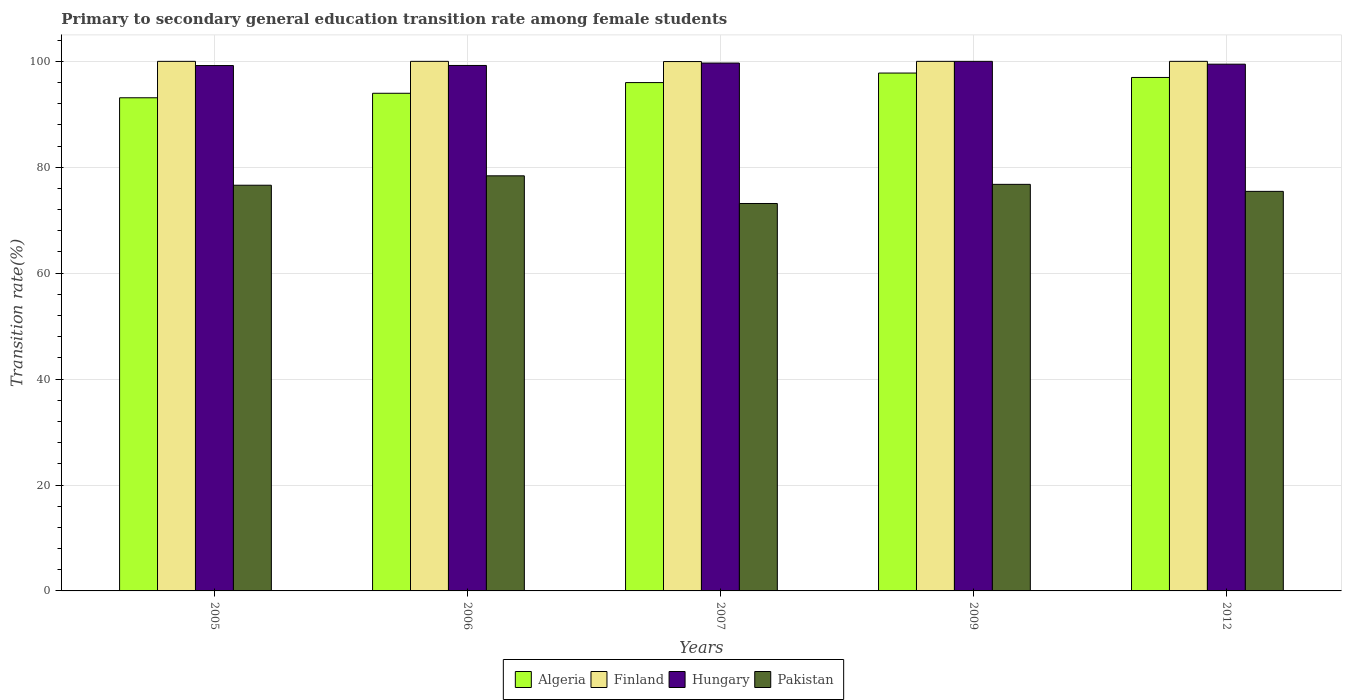How many different coloured bars are there?
Offer a terse response. 4. Are the number of bars per tick equal to the number of legend labels?
Keep it short and to the point. Yes. Are the number of bars on each tick of the X-axis equal?
Keep it short and to the point. Yes. How many bars are there on the 5th tick from the left?
Your answer should be very brief. 4. How many bars are there on the 2nd tick from the right?
Offer a terse response. 4. In how many cases, is the number of bars for a given year not equal to the number of legend labels?
Make the answer very short. 0. What is the transition rate in Pakistan in 2012?
Keep it short and to the point. 75.45. Across all years, what is the minimum transition rate in Algeria?
Your answer should be very brief. 93.12. What is the total transition rate in Hungary in the graph?
Offer a terse response. 497.57. What is the difference between the transition rate in Hungary in 2005 and that in 2012?
Your answer should be compact. -0.26. What is the difference between the transition rate in Hungary in 2009 and the transition rate in Finland in 2012?
Offer a very short reply. 0. What is the average transition rate in Pakistan per year?
Offer a terse response. 76.07. In the year 2012, what is the difference between the transition rate in Finland and transition rate in Pakistan?
Give a very brief answer. 24.55. In how many years, is the transition rate in Pakistan greater than 84 %?
Your answer should be very brief. 0. What is the ratio of the transition rate in Algeria in 2006 to that in 2009?
Your answer should be very brief. 0.96. Is the transition rate in Algeria in 2005 less than that in 2006?
Your answer should be compact. Yes. Is the difference between the transition rate in Finland in 2005 and 2007 greater than the difference between the transition rate in Pakistan in 2005 and 2007?
Your response must be concise. No. What is the difference between the highest and the lowest transition rate in Finland?
Ensure brevity in your answer.  0.04. In how many years, is the transition rate in Finland greater than the average transition rate in Finland taken over all years?
Ensure brevity in your answer.  4. Is it the case that in every year, the sum of the transition rate in Hungary and transition rate in Finland is greater than the sum of transition rate in Algeria and transition rate in Pakistan?
Keep it short and to the point. Yes. What does the 1st bar from the left in 2012 represents?
Provide a succinct answer. Algeria. What does the 3rd bar from the right in 2006 represents?
Your answer should be very brief. Finland. Is it the case that in every year, the sum of the transition rate in Finland and transition rate in Pakistan is greater than the transition rate in Algeria?
Provide a short and direct response. Yes. How many bars are there?
Provide a succinct answer. 20. How many years are there in the graph?
Offer a terse response. 5. Are the values on the major ticks of Y-axis written in scientific E-notation?
Offer a very short reply. No. Does the graph contain grids?
Provide a succinct answer. Yes. How are the legend labels stacked?
Your answer should be compact. Horizontal. What is the title of the graph?
Your answer should be very brief. Primary to secondary general education transition rate among female students. Does "Latin America(developing only)" appear as one of the legend labels in the graph?
Your answer should be very brief. No. What is the label or title of the Y-axis?
Offer a terse response. Transition rate(%). What is the Transition rate(%) in Algeria in 2005?
Offer a terse response. 93.12. What is the Transition rate(%) in Finland in 2005?
Your answer should be compact. 100. What is the Transition rate(%) of Hungary in 2005?
Offer a very short reply. 99.21. What is the Transition rate(%) in Pakistan in 2005?
Your answer should be very brief. 76.61. What is the Transition rate(%) of Algeria in 2006?
Offer a terse response. 93.97. What is the Transition rate(%) in Finland in 2006?
Offer a very short reply. 100. What is the Transition rate(%) of Hungary in 2006?
Provide a succinct answer. 99.22. What is the Transition rate(%) of Pakistan in 2006?
Ensure brevity in your answer.  78.38. What is the Transition rate(%) in Algeria in 2007?
Your response must be concise. 95.99. What is the Transition rate(%) in Finland in 2007?
Keep it short and to the point. 99.96. What is the Transition rate(%) in Hungary in 2007?
Your response must be concise. 99.68. What is the Transition rate(%) of Pakistan in 2007?
Your answer should be compact. 73.16. What is the Transition rate(%) of Algeria in 2009?
Provide a short and direct response. 97.79. What is the Transition rate(%) in Pakistan in 2009?
Provide a short and direct response. 76.77. What is the Transition rate(%) of Algeria in 2012?
Provide a succinct answer. 96.96. What is the Transition rate(%) of Hungary in 2012?
Offer a very short reply. 99.47. What is the Transition rate(%) of Pakistan in 2012?
Provide a short and direct response. 75.45. Across all years, what is the maximum Transition rate(%) of Algeria?
Give a very brief answer. 97.79. Across all years, what is the maximum Transition rate(%) of Pakistan?
Ensure brevity in your answer.  78.38. Across all years, what is the minimum Transition rate(%) in Algeria?
Your response must be concise. 93.12. Across all years, what is the minimum Transition rate(%) of Finland?
Give a very brief answer. 99.96. Across all years, what is the minimum Transition rate(%) of Hungary?
Make the answer very short. 99.21. Across all years, what is the minimum Transition rate(%) of Pakistan?
Ensure brevity in your answer.  73.16. What is the total Transition rate(%) of Algeria in the graph?
Give a very brief answer. 477.84. What is the total Transition rate(%) of Finland in the graph?
Your answer should be compact. 499.96. What is the total Transition rate(%) in Hungary in the graph?
Keep it short and to the point. 497.57. What is the total Transition rate(%) in Pakistan in the graph?
Provide a short and direct response. 380.37. What is the difference between the Transition rate(%) in Algeria in 2005 and that in 2006?
Ensure brevity in your answer.  -0.85. What is the difference between the Transition rate(%) of Hungary in 2005 and that in 2006?
Your response must be concise. -0.02. What is the difference between the Transition rate(%) in Pakistan in 2005 and that in 2006?
Your answer should be very brief. -1.78. What is the difference between the Transition rate(%) of Algeria in 2005 and that in 2007?
Keep it short and to the point. -2.87. What is the difference between the Transition rate(%) in Finland in 2005 and that in 2007?
Your response must be concise. 0.04. What is the difference between the Transition rate(%) in Hungary in 2005 and that in 2007?
Your answer should be very brief. -0.47. What is the difference between the Transition rate(%) of Pakistan in 2005 and that in 2007?
Keep it short and to the point. 3.45. What is the difference between the Transition rate(%) of Algeria in 2005 and that in 2009?
Your answer should be very brief. -4.67. What is the difference between the Transition rate(%) in Hungary in 2005 and that in 2009?
Your answer should be very brief. -0.79. What is the difference between the Transition rate(%) of Pakistan in 2005 and that in 2009?
Ensure brevity in your answer.  -0.17. What is the difference between the Transition rate(%) in Algeria in 2005 and that in 2012?
Offer a very short reply. -3.84. What is the difference between the Transition rate(%) of Finland in 2005 and that in 2012?
Give a very brief answer. 0. What is the difference between the Transition rate(%) of Hungary in 2005 and that in 2012?
Keep it short and to the point. -0.26. What is the difference between the Transition rate(%) in Pakistan in 2005 and that in 2012?
Your answer should be very brief. 1.16. What is the difference between the Transition rate(%) of Algeria in 2006 and that in 2007?
Your answer should be compact. -2.02. What is the difference between the Transition rate(%) of Finland in 2006 and that in 2007?
Your response must be concise. 0.04. What is the difference between the Transition rate(%) of Hungary in 2006 and that in 2007?
Provide a succinct answer. -0.46. What is the difference between the Transition rate(%) in Pakistan in 2006 and that in 2007?
Provide a short and direct response. 5.23. What is the difference between the Transition rate(%) in Algeria in 2006 and that in 2009?
Give a very brief answer. -3.82. What is the difference between the Transition rate(%) in Hungary in 2006 and that in 2009?
Provide a short and direct response. -0.78. What is the difference between the Transition rate(%) in Pakistan in 2006 and that in 2009?
Give a very brief answer. 1.61. What is the difference between the Transition rate(%) in Algeria in 2006 and that in 2012?
Provide a succinct answer. -2.99. What is the difference between the Transition rate(%) of Hungary in 2006 and that in 2012?
Make the answer very short. -0.24. What is the difference between the Transition rate(%) in Pakistan in 2006 and that in 2012?
Give a very brief answer. 2.93. What is the difference between the Transition rate(%) of Algeria in 2007 and that in 2009?
Ensure brevity in your answer.  -1.8. What is the difference between the Transition rate(%) of Finland in 2007 and that in 2009?
Offer a terse response. -0.04. What is the difference between the Transition rate(%) of Hungary in 2007 and that in 2009?
Your answer should be very brief. -0.32. What is the difference between the Transition rate(%) of Pakistan in 2007 and that in 2009?
Your answer should be compact. -3.62. What is the difference between the Transition rate(%) in Algeria in 2007 and that in 2012?
Provide a short and direct response. -0.97. What is the difference between the Transition rate(%) of Finland in 2007 and that in 2012?
Offer a terse response. -0.04. What is the difference between the Transition rate(%) of Hungary in 2007 and that in 2012?
Make the answer very short. 0.21. What is the difference between the Transition rate(%) in Pakistan in 2007 and that in 2012?
Offer a very short reply. -2.29. What is the difference between the Transition rate(%) in Algeria in 2009 and that in 2012?
Offer a terse response. 0.83. What is the difference between the Transition rate(%) in Hungary in 2009 and that in 2012?
Offer a very short reply. 0.53. What is the difference between the Transition rate(%) in Pakistan in 2009 and that in 2012?
Make the answer very short. 1.32. What is the difference between the Transition rate(%) of Algeria in 2005 and the Transition rate(%) of Finland in 2006?
Offer a very short reply. -6.88. What is the difference between the Transition rate(%) in Algeria in 2005 and the Transition rate(%) in Hungary in 2006?
Give a very brief answer. -6.1. What is the difference between the Transition rate(%) in Algeria in 2005 and the Transition rate(%) in Pakistan in 2006?
Make the answer very short. 14.74. What is the difference between the Transition rate(%) of Finland in 2005 and the Transition rate(%) of Hungary in 2006?
Provide a succinct answer. 0.78. What is the difference between the Transition rate(%) in Finland in 2005 and the Transition rate(%) in Pakistan in 2006?
Offer a terse response. 21.62. What is the difference between the Transition rate(%) in Hungary in 2005 and the Transition rate(%) in Pakistan in 2006?
Ensure brevity in your answer.  20.82. What is the difference between the Transition rate(%) in Algeria in 2005 and the Transition rate(%) in Finland in 2007?
Your answer should be compact. -6.84. What is the difference between the Transition rate(%) in Algeria in 2005 and the Transition rate(%) in Hungary in 2007?
Provide a succinct answer. -6.56. What is the difference between the Transition rate(%) in Algeria in 2005 and the Transition rate(%) in Pakistan in 2007?
Provide a succinct answer. 19.96. What is the difference between the Transition rate(%) of Finland in 2005 and the Transition rate(%) of Hungary in 2007?
Make the answer very short. 0.32. What is the difference between the Transition rate(%) of Finland in 2005 and the Transition rate(%) of Pakistan in 2007?
Offer a very short reply. 26.84. What is the difference between the Transition rate(%) of Hungary in 2005 and the Transition rate(%) of Pakistan in 2007?
Your answer should be compact. 26.05. What is the difference between the Transition rate(%) in Algeria in 2005 and the Transition rate(%) in Finland in 2009?
Your answer should be compact. -6.88. What is the difference between the Transition rate(%) in Algeria in 2005 and the Transition rate(%) in Hungary in 2009?
Your answer should be compact. -6.88. What is the difference between the Transition rate(%) in Algeria in 2005 and the Transition rate(%) in Pakistan in 2009?
Provide a short and direct response. 16.35. What is the difference between the Transition rate(%) in Finland in 2005 and the Transition rate(%) in Pakistan in 2009?
Your answer should be very brief. 23.23. What is the difference between the Transition rate(%) of Hungary in 2005 and the Transition rate(%) of Pakistan in 2009?
Your response must be concise. 22.43. What is the difference between the Transition rate(%) in Algeria in 2005 and the Transition rate(%) in Finland in 2012?
Ensure brevity in your answer.  -6.88. What is the difference between the Transition rate(%) of Algeria in 2005 and the Transition rate(%) of Hungary in 2012?
Keep it short and to the point. -6.34. What is the difference between the Transition rate(%) in Algeria in 2005 and the Transition rate(%) in Pakistan in 2012?
Offer a very short reply. 17.67. What is the difference between the Transition rate(%) in Finland in 2005 and the Transition rate(%) in Hungary in 2012?
Your response must be concise. 0.53. What is the difference between the Transition rate(%) in Finland in 2005 and the Transition rate(%) in Pakistan in 2012?
Give a very brief answer. 24.55. What is the difference between the Transition rate(%) of Hungary in 2005 and the Transition rate(%) of Pakistan in 2012?
Offer a very short reply. 23.76. What is the difference between the Transition rate(%) in Algeria in 2006 and the Transition rate(%) in Finland in 2007?
Give a very brief answer. -5.99. What is the difference between the Transition rate(%) of Algeria in 2006 and the Transition rate(%) of Hungary in 2007?
Ensure brevity in your answer.  -5.71. What is the difference between the Transition rate(%) of Algeria in 2006 and the Transition rate(%) of Pakistan in 2007?
Your answer should be very brief. 20.81. What is the difference between the Transition rate(%) of Finland in 2006 and the Transition rate(%) of Hungary in 2007?
Make the answer very short. 0.32. What is the difference between the Transition rate(%) in Finland in 2006 and the Transition rate(%) in Pakistan in 2007?
Give a very brief answer. 26.84. What is the difference between the Transition rate(%) of Hungary in 2006 and the Transition rate(%) of Pakistan in 2007?
Ensure brevity in your answer.  26.07. What is the difference between the Transition rate(%) of Algeria in 2006 and the Transition rate(%) of Finland in 2009?
Your answer should be very brief. -6.03. What is the difference between the Transition rate(%) of Algeria in 2006 and the Transition rate(%) of Hungary in 2009?
Provide a succinct answer. -6.03. What is the difference between the Transition rate(%) in Algeria in 2006 and the Transition rate(%) in Pakistan in 2009?
Offer a terse response. 17.2. What is the difference between the Transition rate(%) in Finland in 2006 and the Transition rate(%) in Pakistan in 2009?
Make the answer very short. 23.23. What is the difference between the Transition rate(%) of Hungary in 2006 and the Transition rate(%) of Pakistan in 2009?
Your answer should be compact. 22.45. What is the difference between the Transition rate(%) of Algeria in 2006 and the Transition rate(%) of Finland in 2012?
Offer a very short reply. -6.03. What is the difference between the Transition rate(%) in Algeria in 2006 and the Transition rate(%) in Hungary in 2012?
Keep it short and to the point. -5.49. What is the difference between the Transition rate(%) of Algeria in 2006 and the Transition rate(%) of Pakistan in 2012?
Your answer should be very brief. 18.52. What is the difference between the Transition rate(%) in Finland in 2006 and the Transition rate(%) in Hungary in 2012?
Your answer should be very brief. 0.53. What is the difference between the Transition rate(%) in Finland in 2006 and the Transition rate(%) in Pakistan in 2012?
Your response must be concise. 24.55. What is the difference between the Transition rate(%) in Hungary in 2006 and the Transition rate(%) in Pakistan in 2012?
Make the answer very short. 23.77. What is the difference between the Transition rate(%) of Algeria in 2007 and the Transition rate(%) of Finland in 2009?
Offer a very short reply. -4.01. What is the difference between the Transition rate(%) of Algeria in 2007 and the Transition rate(%) of Hungary in 2009?
Your answer should be very brief. -4.01. What is the difference between the Transition rate(%) of Algeria in 2007 and the Transition rate(%) of Pakistan in 2009?
Offer a terse response. 19.22. What is the difference between the Transition rate(%) in Finland in 2007 and the Transition rate(%) in Hungary in 2009?
Make the answer very short. -0.04. What is the difference between the Transition rate(%) in Finland in 2007 and the Transition rate(%) in Pakistan in 2009?
Your response must be concise. 23.19. What is the difference between the Transition rate(%) in Hungary in 2007 and the Transition rate(%) in Pakistan in 2009?
Provide a short and direct response. 22.9. What is the difference between the Transition rate(%) in Algeria in 2007 and the Transition rate(%) in Finland in 2012?
Provide a succinct answer. -4.01. What is the difference between the Transition rate(%) in Algeria in 2007 and the Transition rate(%) in Hungary in 2012?
Offer a terse response. -3.48. What is the difference between the Transition rate(%) in Algeria in 2007 and the Transition rate(%) in Pakistan in 2012?
Your answer should be compact. 20.54. What is the difference between the Transition rate(%) in Finland in 2007 and the Transition rate(%) in Hungary in 2012?
Offer a very short reply. 0.5. What is the difference between the Transition rate(%) of Finland in 2007 and the Transition rate(%) of Pakistan in 2012?
Provide a short and direct response. 24.51. What is the difference between the Transition rate(%) of Hungary in 2007 and the Transition rate(%) of Pakistan in 2012?
Provide a succinct answer. 24.23. What is the difference between the Transition rate(%) of Algeria in 2009 and the Transition rate(%) of Finland in 2012?
Your answer should be very brief. -2.21. What is the difference between the Transition rate(%) in Algeria in 2009 and the Transition rate(%) in Hungary in 2012?
Your answer should be very brief. -1.67. What is the difference between the Transition rate(%) in Algeria in 2009 and the Transition rate(%) in Pakistan in 2012?
Ensure brevity in your answer.  22.34. What is the difference between the Transition rate(%) of Finland in 2009 and the Transition rate(%) of Hungary in 2012?
Offer a terse response. 0.53. What is the difference between the Transition rate(%) in Finland in 2009 and the Transition rate(%) in Pakistan in 2012?
Provide a short and direct response. 24.55. What is the difference between the Transition rate(%) of Hungary in 2009 and the Transition rate(%) of Pakistan in 2012?
Your answer should be very brief. 24.55. What is the average Transition rate(%) in Algeria per year?
Ensure brevity in your answer.  95.57. What is the average Transition rate(%) of Finland per year?
Keep it short and to the point. 99.99. What is the average Transition rate(%) in Hungary per year?
Offer a very short reply. 99.52. What is the average Transition rate(%) in Pakistan per year?
Make the answer very short. 76.07. In the year 2005, what is the difference between the Transition rate(%) of Algeria and Transition rate(%) of Finland?
Offer a very short reply. -6.88. In the year 2005, what is the difference between the Transition rate(%) of Algeria and Transition rate(%) of Hungary?
Offer a very short reply. -6.08. In the year 2005, what is the difference between the Transition rate(%) in Algeria and Transition rate(%) in Pakistan?
Ensure brevity in your answer.  16.52. In the year 2005, what is the difference between the Transition rate(%) in Finland and Transition rate(%) in Hungary?
Your response must be concise. 0.79. In the year 2005, what is the difference between the Transition rate(%) in Finland and Transition rate(%) in Pakistan?
Provide a short and direct response. 23.39. In the year 2005, what is the difference between the Transition rate(%) in Hungary and Transition rate(%) in Pakistan?
Your response must be concise. 22.6. In the year 2006, what is the difference between the Transition rate(%) of Algeria and Transition rate(%) of Finland?
Give a very brief answer. -6.03. In the year 2006, what is the difference between the Transition rate(%) in Algeria and Transition rate(%) in Hungary?
Your answer should be compact. -5.25. In the year 2006, what is the difference between the Transition rate(%) of Algeria and Transition rate(%) of Pakistan?
Make the answer very short. 15.59. In the year 2006, what is the difference between the Transition rate(%) of Finland and Transition rate(%) of Hungary?
Provide a succinct answer. 0.78. In the year 2006, what is the difference between the Transition rate(%) in Finland and Transition rate(%) in Pakistan?
Offer a terse response. 21.62. In the year 2006, what is the difference between the Transition rate(%) in Hungary and Transition rate(%) in Pakistan?
Your answer should be very brief. 20.84. In the year 2007, what is the difference between the Transition rate(%) in Algeria and Transition rate(%) in Finland?
Keep it short and to the point. -3.97. In the year 2007, what is the difference between the Transition rate(%) in Algeria and Transition rate(%) in Hungary?
Make the answer very short. -3.69. In the year 2007, what is the difference between the Transition rate(%) of Algeria and Transition rate(%) of Pakistan?
Offer a terse response. 22.83. In the year 2007, what is the difference between the Transition rate(%) of Finland and Transition rate(%) of Hungary?
Offer a terse response. 0.28. In the year 2007, what is the difference between the Transition rate(%) of Finland and Transition rate(%) of Pakistan?
Offer a terse response. 26.8. In the year 2007, what is the difference between the Transition rate(%) in Hungary and Transition rate(%) in Pakistan?
Ensure brevity in your answer.  26.52. In the year 2009, what is the difference between the Transition rate(%) in Algeria and Transition rate(%) in Finland?
Offer a very short reply. -2.21. In the year 2009, what is the difference between the Transition rate(%) in Algeria and Transition rate(%) in Hungary?
Your answer should be compact. -2.21. In the year 2009, what is the difference between the Transition rate(%) in Algeria and Transition rate(%) in Pakistan?
Provide a succinct answer. 21.02. In the year 2009, what is the difference between the Transition rate(%) of Finland and Transition rate(%) of Pakistan?
Provide a succinct answer. 23.23. In the year 2009, what is the difference between the Transition rate(%) of Hungary and Transition rate(%) of Pakistan?
Offer a terse response. 23.23. In the year 2012, what is the difference between the Transition rate(%) in Algeria and Transition rate(%) in Finland?
Provide a short and direct response. -3.04. In the year 2012, what is the difference between the Transition rate(%) of Algeria and Transition rate(%) of Hungary?
Provide a succinct answer. -2.51. In the year 2012, what is the difference between the Transition rate(%) of Algeria and Transition rate(%) of Pakistan?
Offer a very short reply. 21.51. In the year 2012, what is the difference between the Transition rate(%) of Finland and Transition rate(%) of Hungary?
Offer a very short reply. 0.53. In the year 2012, what is the difference between the Transition rate(%) in Finland and Transition rate(%) in Pakistan?
Keep it short and to the point. 24.55. In the year 2012, what is the difference between the Transition rate(%) in Hungary and Transition rate(%) in Pakistan?
Your answer should be compact. 24.02. What is the ratio of the Transition rate(%) of Algeria in 2005 to that in 2006?
Provide a short and direct response. 0.99. What is the ratio of the Transition rate(%) of Finland in 2005 to that in 2006?
Offer a very short reply. 1. What is the ratio of the Transition rate(%) of Hungary in 2005 to that in 2006?
Offer a terse response. 1. What is the ratio of the Transition rate(%) in Pakistan in 2005 to that in 2006?
Your answer should be compact. 0.98. What is the ratio of the Transition rate(%) of Algeria in 2005 to that in 2007?
Give a very brief answer. 0.97. What is the ratio of the Transition rate(%) of Finland in 2005 to that in 2007?
Offer a very short reply. 1. What is the ratio of the Transition rate(%) in Pakistan in 2005 to that in 2007?
Your answer should be very brief. 1.05. What is the ratio of the Transition rate(%) of Algeria in 2005 to that in 2009?
Offer a terse response. 0.95. What is the ratio of the Transition rate(%) in Pakistan in 2005 to that in 2009?
Provide a short and direct response. 1. What is the ratio of the Transition rate(%) of Algeria in 2005 to that in 2012?
Keep it short and to the point. 0.96. What is the ratio of the Transition rate(%) in Finland in 2005 to that in 2012?
Your response must be concise. 1. What is the ratio of the Transition rate(%) of Hungary in 2005 to that in 2012?
Provide a succinct answer. 1. What is the ratio of the Transition rate(%) in Pakistan in 2005 to that in 2012?
Keep it short and to the point. 1.02. What is the ratio of the Transition rate(%) in Algeria in 2006 to that in 2007?
Your answer should be very brief. 0.98. What is the ratio of the Transition rate(%) in Hungary in 2006 to that in 2007?
Keep it short and to the point. 1. What is the ratio of the Transition rate(%) of Pakistan in 2006 to that in 2007?
Your answer should be compact. 1.07. What is the ratio of the Transition rate(%) of Algeria in 2006 to that in 2009?
Ensure brevity in your answer.  0.96. What is the ratio of the Transition rate(%) in Hungary in 2006 to that in 2009?
Ensure brevity in your answer.  0.99. What is the ratio of the Transition rate(%) in Algeria in 2006 to that in 2012?
Your response must be concise. 0.97. What is the ratio of the Transition rate(%) in Finland in 2006 to that in 2012?
Offer a very short reply. 1. What is the ratio of the Transition rate(%) of Hungary in 2006 to that in 2012?
Give a very brief answer. 1. What is the ratio of the Transition rate(%) of Pakistan in 2006 to that in 2012?
Your answer should be compact. 1.04. What is the ratio of the Transition rate(%) of Algeria in 2007 to that in 2009?
Keep it short and to the point. 0.98. What is the ratio of the Transition rate(%) in Hungary in 2007 to that in 2009?
Provide a succinct answer. 1. What is the ratio of the Transition rate(%) of Pakistan in 2007 to that in 2009?
Offer a very short reply. 0.95. What is the ratio of the Transition rate(%) in Finland in 2007 to that in 2012?
Keep it short and to the point. 1. What is the ratio of the Transition rate(%) of Pakistan in 2007 to that in 2012?
Provide a short and direct response. 0.97. What is the ratio of the Transition rate(%) of Algeria in 2009 to that in 2012?
Keep it short and to the point. 1.01. What is the ratio of the Transition rate(%) in Finland in 2009 to that in 2012?
Offer a very short reply. 1. What is the ratio of the Transition rate(%) in Hungary in 2009 to that in 2012?
Ensure brevity in your answer.  1.01. What is the ratio of the Transition rate(%) of Pakistan in 2009 to that in 2012?
Your answer should be very brief. 1.02. What is the difference between the highest and the second highest Transition rate(%) in Algeria?
Your answer should be very brief. 0.83. What is the difference between the highest and the second highest Transition rate(%) of Finland?
Your response must be concise. 0. What is the difference between the highest and the second highest Transition rate(%) in Hungary?
Your answer should be compact. 0.32. What is the difference between the highest and the second highest Transition rate(%) in Pakistan?
Make the answer very short. 1.61. What is the difference between the highest and the lowest Transition rate(%) of Algeria?
Offer a terse response. 4.67. What is the difference between the highest and the lowest Transition rate(%) of Finland?
Your answer should be compact. 0.04. What is the difference between the highest and the lowest Transition rate(%) in Hungary?
Ensure brevity in your answer.  0.79. What is the difference between the highest and the lowest Transition rate(%) in Pakistan?
Give a very brief answer. 5.23. 